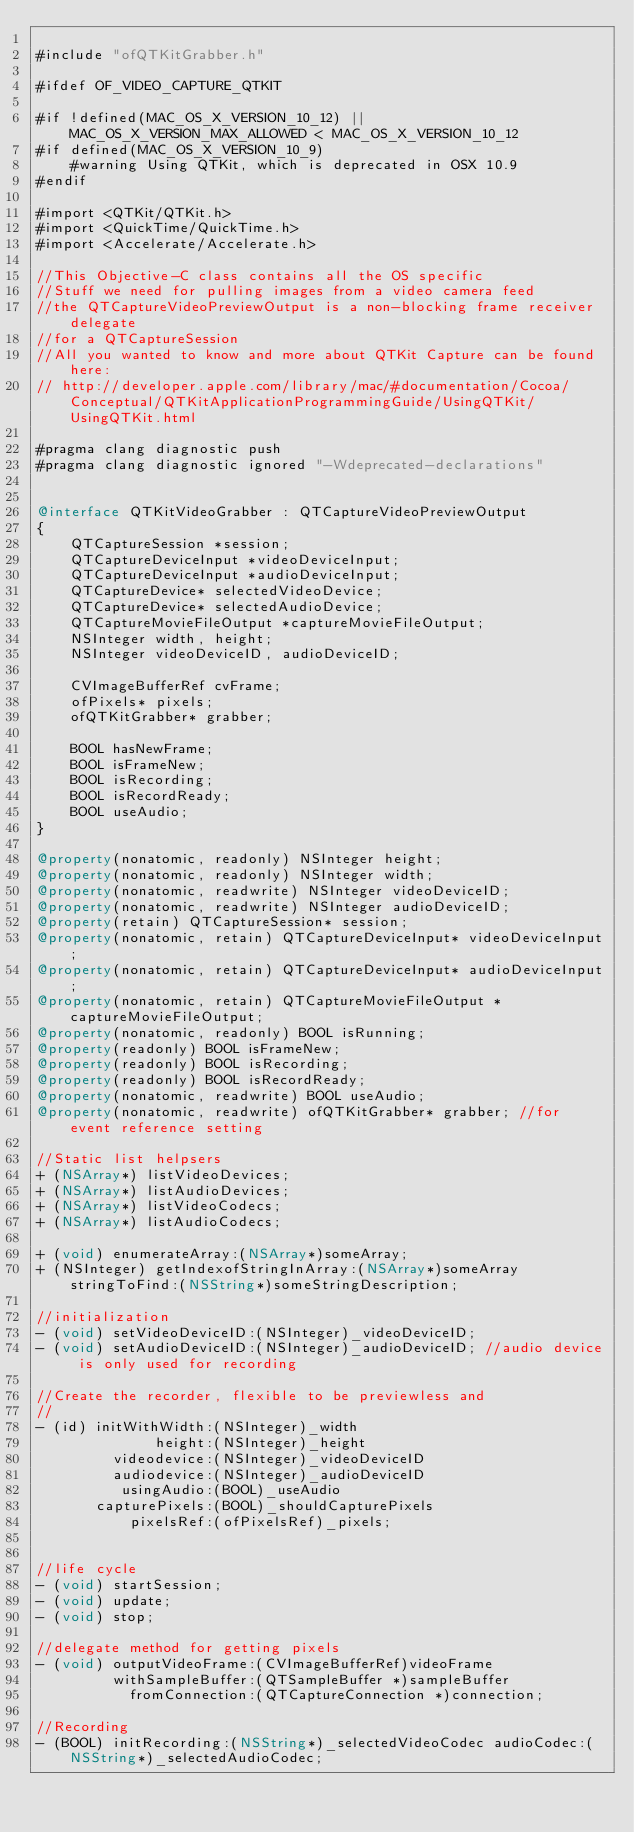<code> <loc_0><loc_0><loc_500><loc_500><_ObjectiveC_>
#include "ofQTKitGrabber.h"

#ifdef OF_VIDEO_CAPTURE_QTKIT

#if !defined(MAC_OS_X_VERSION_10_12) || MAC_OS_X_VERSION_MAX_ALLOWED < MAC_OS_X_VERSION_10_12
#if defined(MAC_OS_X_VERSION_10_9)
	#warning Using QTKit, which is deprecated in OSX 10.9
#endif

#import <QTKit/QTKit.h>
#import <QuickTime/QuickTime.h>
#import <Accelerate/Accelerate.h>

//This Objective-C class contains all the OS specific
//Stuff we need for pulling images from a video camera feed
//the QTCaptureVideoPreviewOutput is a non-blocking frame receiver delegate
//for a QTCaptureSession
//All you wanted to know and more about QTKit Capture can be found here:
// http://developer.apple.com/library/mac/#documentation/Cocoa/Conceptual/QTKitApplicationProgrammingGuide/UsingQTKit/UsingQTKit.html

#pragma clang diagnostic push
#pragma clang diagnostic ignored "-Wdeprecated-declarations"


@interface QTKitVideoGrabber : QTCaptureVideoPreviewOutput
{
    QTCaptureSession *session;
    QTCaptureDeviceInput *videoDeviceInput;
    QTCaptureDeviceInput *audioDeviceInput;
    QTCaptureDevice* selectedVideoDevice;
    QTCaptureDevice* selectedAudioDevice;
    QTCaptureMovieFileOutput *captureMovieFileOutput;
    NSInteger width, height;
    NSInteger videoDeviceID, audioDeviceID;

    CVImageBufferRef cvFrame;
    ofPixels* pixels;
	ofQTKitGrabber* grabber;
	
    BOOL hasNewFrame;
    BOOL isFrameNew;
    BOOL isRecording;
    BOOL isRecordReady;
    BOOL useAudio;
}

@property(nonatomic, readonly) NSInteger height;
@property(nonatomic, readonly) NSInteger width;
@property(nonatomic, readwrite) NSInteger videoDeviceID;
@property(nonatomic, readwrite) NSInteger audioDeviceID;
@property(retain) QTCaptureSession* session;
@property(nonatomic, retain) QTCaptureDeviceInput* videoDeviceInput;
@property(nonatomic, retain) QTCaptureDeviceInput* audioDeviceInput;
@property(nonatomic, retain) QTCaptureMovieFileOutput *captureMovieFileOutput;
@property(nonatomic, readonly) BOOL isRunning;
@property(readonly) BOOL isFrameNew;
@property(readonly) BOOL isRecording;
@property(readonly) BOOL isRecordReady;
@property(nonatomic, readwrite) BOOL useAudio;
@property(nonatomic, readwrite) ofQTKitGrabber* grabber; //for event reference setting

//Static list helpsers
+ (NSArray*) listVideoDevices;
+ (NSArray*) listAudioDevices;
+ (NSArray*) listVideoCodecs;
+ (NSArray*) listAudioCodecs;

+ (void) enumerateArray:(NSArray*)someArray;
+ (NSInteger) getIndexofStringInArray:(NSArray*)someArray stringToFind:(NSString*)someStringDescription;

//initialization
- (void) setVideoDeviceID:(NSInteger)_videoDeviceID;
- (void) setAudioDeviceID:(NSInteger)_audioDeviceID; //audio device is only used for recording

//Create the recorder, flexible to be previewless and
//
- (id) initWithWidth:(NSInteger)_width
              height:(NSInteger)_height
         videodevice:(NSInteger)_videoDeviceID
         audiodevice:(NSInteger)_audioDeviceID
          usingAudio:(BOOL)_useAudio
	   capturePixels:(BOOL)_shouldCapturePixels
           pixelsRef:(ofPixelsRef)_pixels;


//life cycle
- (void) startSession;
- (void) update;
- (void) stop;

//delegate method for getting pixels
- (void) outputVideoFrame:(CVImageBufferRef)videoFrame 
		 withSampleBuffer:(QTSampleBuffer *)sampleBuffer 
		   fromConnection:(QTCaptureConnection *)connection;

//Recording
- (BOOL) initRecording:(NSString*)_selectedVideoCodec audioCodec:(NSString*)_selectedAudioCodec;</code> 